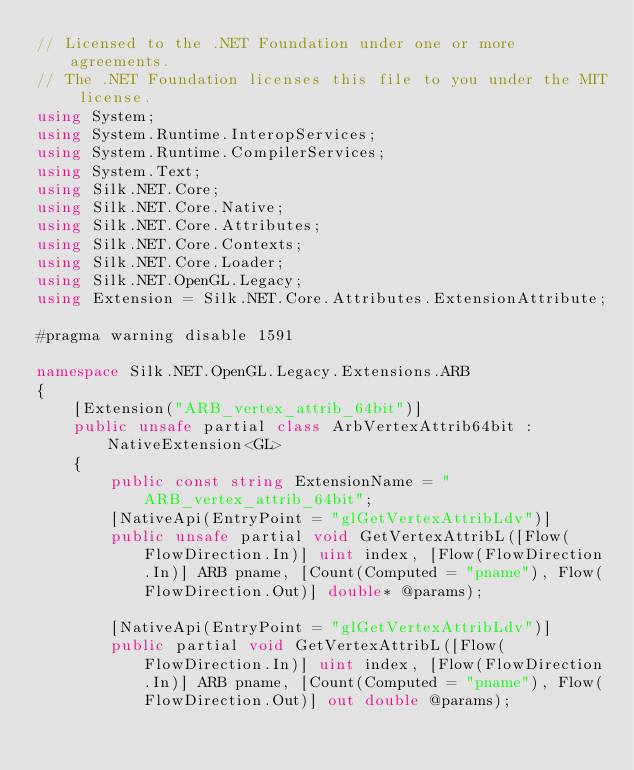Convert code to text. <code><loc_0><loc_0><loc_500><loc_500><_C#_>// Licensed to the .NET Foundation under one or more agreements.
// The .NET Foundation licenses this file to you under the MIT license.
using System;
using System.Runtime.InteropServices;
using System.Runtime.CompilerServices;
using System.Text;
using Silk.NET.Core;
using Silk.NET.Core.Native;
using Silk.NET.Core.Attributes;
using Silk.NET.Core.Contexts;
using Silk.NET.Core.Loader;
using Silk.NET.OpenGL.Legacy;
using Extension = Silk.NET.Core.Attributes.ExtensionAttribute;

#pragma warning disable 1591

namespace Silk.NET.OpenGL.Legacy.Extensions.ARB
{
    [Extension("ARB_vertex_attrib_64bit")]
    public unsafe partial class ArbVertexAttrib64bit : NativeExtension<GL>
    {
        public const string ExtensionName = "ARB_vertex_attrib_64bit";
        [NativeApi(EntryPoint = "glGetVertexAttribLdv")]
        public unsafe partial void GetVertexAttribL([Flow(FlowDirection.In)] uint index, [Flow(FlowDirection.In)] ARB pname, [Count(Computed = "pname"), Flow(FlowDirection.Out)] double* @params);

        [NativeApi(EntryPoint = "glGetVertexAttribLdv")]
        public partial void GetVertexAttribL([Flow(FlowDirection.In)] uint index, [Flow(FlowDirection.In)] ARB pname, [Count(Computed = "pname"), Flow(FlowDirection.Out)] out double @params);
</code> 